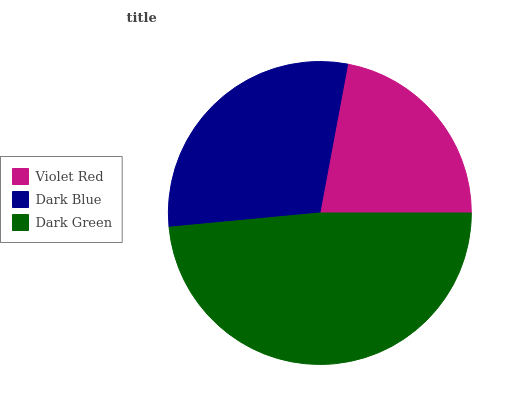Is Violet Red the minimum?
Answer yes or no. Yes. Is Dark Green the maximum?
Answer yes or no. Yes. Is Dark Blue the minimum?
Answer yes or no. No. Is Dark Blue the maximum?
Answer yes or no. No. Is Dark Blue greater than Violet Red?
Answer yes or no. Yes. Is Violet Red less than Dark Blue?
Answer yes or no. Yes. Is Violet Red greater than Dark Blue?
Answer yes or no. No. Is Dark Blue less than Violet Red?
Answer yes or no. No. Is Dark Blue the high median?
Answer yes or no. Yes. Is Dark Blue the low median?
Answer yes or no. Yes. Is Dark Green the high median?
Answer yes or no. No. Is Violet Red the low median?
Answer yes or no. No. 